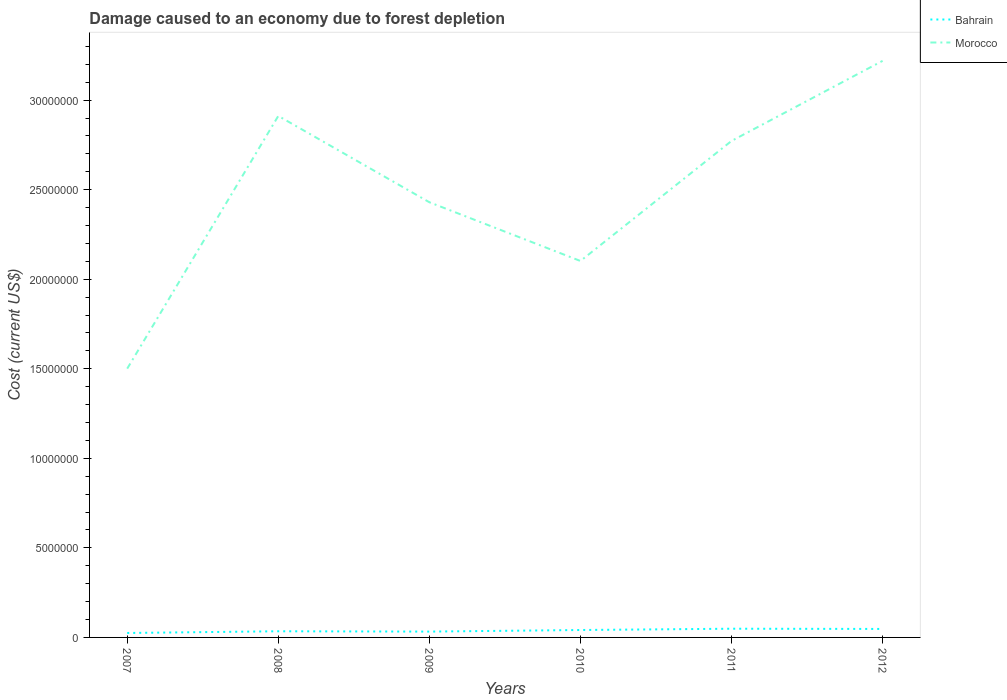Is the number of lines equal to the number of legend labels?
Provide a succinct answer. Yes. Across all years, what is the maximum cost of damage caused due to forest depletion in Bahrain?
Your response must be concise. 2.48e+05. What is the total cost of damage caused due to forest depletion in Bahrain in the graph?
Keep it short and to the point. -1.66e+05. What is the difference between the highest and the second highest cost of damage caused due to forest depletion in Morocco?
Provide a succinct answer. 1.72e+07. Is the cost of damage caused due to forest depletion in Bahrain strictly greater than the cost of damage caused due to forest depletion in Morocco over the years?
Provide a short and direct response. Yes. How many years are there in the graph?
Your answer should be compact. 6. Where does the legend appear in the graph?
Provide a succinct answer. Top right. How are the legend labels stacked?
Give a very brief answer. Vertical. What is the title of the graph?
Provide a short and direct response. Damage caused to an economy due to forest depletion. What is the label or title of the X-axis?
Provide a succinct answer. Years. What is the label or title of the Y-axis?
Your answer should be compact. Cost (current US$). What is the Cost (current US$) of Bahrain in 2007?
Provide a short and direct response. 2.48e+05. What is the Cost (current US$) in Morocco in 2007?
Give a very brief answer. 1.50e+07. What is the Cost (current US$) of Bahrain in 2008?
Your answer should be very brief. 3.44e+05. What is the Cost (current US$) of Morocco in 2008?
Provide a succinct answer. 2.91e+07. What is the Cost (current US$) of Bahrain in 2009?
Offer a very short reply. 3.26e+05. What is the Cost (current US$) of Morocco in 2009?
Your response must be concise. 2.43e+07. What is the Cost (current US$) of Bahrain in 2010?
Your answer should be compact. 4.14e+05. What is the Cost (current US$) of Morocco in 2010?
Ensure brevity in your answer.  2.10e+07. What is the Cost (current US$) in Bahrain in 2011?
Your response must be concise. 4.86e+05. What is the Cost (current US$) of Morocco in 2011?
Ensure brevity in your answer.  2.77e+07. What is the Cost (current US$) in Bahrain in 2012?
Offer a terse response. 4.73e+05. What is the Cost (current US$) in Morocco in 2012?
Make the answer very short. 3.22e+07. Across all years, what is the maximum Cost (current US$) of Bahrain?
Provide a short and direct response. 4.86e+05. Across all years, what is the maximum Cost (current US$) of Morocco?
Offer a terse response. 3.22e+07. Across all years, what is the minimum Cost (current US$) in Bahrain?
Give a very brief answer. 2.48e+05. Across all years, what is the minimum Cost (current US$) in Morocco?
Ensure brevity in your answer.  1.50e+07. What is the total Cost (current US$) in Bahrain in the graph?
Offer a very short reply. 2.29e+06. What is the total Cost (current US$) of Morocco in the graph?
Offer a terse response. 1.49e+08. What is the difference between the Cost (current US$) of Bahrain in 2007 and that in 2008?
Keep it short and to the point. -9.60e+04. What is the difference between the Cost (current US$) in Morocco in 2007 and that in 2008?
Provide a succinct answer. -1.41e+07. What is the difference between the Cost (current US$) in Bahrain in 2007 and that in 2009?
Provide a succinct answer. -7.75e+04. What is the difference between the Cost (current US$) of Morocco in 2007 and that in 2009?
Offer a very short reply. -9.29e+06. What is the difference between the Cost (current US$) of Bahrain in 2007 and that in 2010?
Give a very brief answer. -1.66e+05. What is the difference between the Cost (current US$) of Morocco in 2007 and that in 2010?
Give a very brief answer. -6.01e+06. What is the difference between the Cost (current US$) in Bahrain in 2007 and that in 2011?
Ensure brevity in your answer.  -2.38e+05. What is the difference between the Cost (current US$) in Morocco in 2007 and that in 2011?
Provide a short and direct response. -1.27e+07. What is the difference between the Cost (current US$) in Bahrain in 2007 and that in 2012?
Offer a terse response. -2.25e+05. What is the difference between the Cost (current US$) in Morocco in 2007 and that in 2012?
Offer a very short reply. -1.72e+07. What is the difference between the Cost (current US$) in Bahrain in 2008 and that in 2009?
Your answer should be compact. 1.85e+04. What is the difference between the Cost (current US$) of Morocco in 2008 and that in 2009?
Your response must be concise. 4.82e+06. What is the difference between the Cost (current US$) in Bahrain in 2008 and that in 2010?
Provide a succinct answer. -7.02e+04. What is the difference between the Cost (current US$) of Morocco in 2008 and that in 2010?
Keep it short and to the point. 8.10e+06. What is the difference between the Cost (current US$) of Bahrain in 2008 and that in 2011?
Give a very brief answer. -1.42e+05. What is the difference between the Cost (current US$) in Morocco in 2008 and that in 2011?
Your answer should be compact. 1.40e+06. What is the difference between the Cost (current US$) in Bahrain in 2008 and that in 2012?
Make the answer very short. -1.29e+05. What is the difference between the Cost (current US$) of Morocco in 2008 and that in 2012?
Give a very brief answer. -3.07e+06. What is the difference between the Cost (current US$) in Bahrain in 2009 and that in 2010?
Provide a short and direct response. -8.86e+04. What is the difference between the Cost (current US$) in Morocco in 2009 and that in 2010?
Provide a succinct answer. 3.28e+06. What is the difference between the Cost (current US$) in Bahrain in 2009 and that in 2011?
Your answer should be compact. -1.61e+05. What is the difference between the Cost (current US$) of Morocco in 2009 and that in 2011?
Provide a succinct answer. -3.42e+06. What is the difference between the Cost (current US$) in Bahrain in 2009 and that in 2012?
Offer a very short reply. -1.48e+05. What is the difference between the Cost (current US$) of Morocco in 2009 and that in 2012?
Make the answer very short. -7.89e+06. What is the difference between the Cost (current US$) of Bahrain in 2010 and that in 2011?
Your response must be concise. -7.19e+04. What is the difference between the Cost (current US$) of Morocco in 2010 and that in 2011?
Ensure brevity in your answer.  -6.70e+06. What is the difference between the Cost (current US$) of Bahrain in 2010 and that in 2012?
Make the answer very short. -5.91e+04. What is the difference between the Cost (current US$) of Morocco in 2010 and that in 2012?
Offer a very short reply. -1.12e+07. What is the difference between the Cost (current US$) of Bahrain in 2011 and that in 2012?
Keep it short and to the point. 1.28e+04. What is the difference between the Cost (current US$) of Morocco in 2011 and that in 2012?
Offer a very short reply. -4.47e+06. What is the difference between the Cost (current US$) of Bahrain in 2007 and the Cost (current US$) of Morocco in 2008?
Your response must be concise. -2.89e+07. What is the difference between the Cost (current US$) in Bahrain in 2007 and the Cost (current US$) in Morocco in 2009?
Your response must be concise. -2.40e+07. What is the difference between the Cost (current US$) of Bahrain in 2007 and the Cost (current US$) of Morocco in 2010?
Your answer should be very brief. -2.08e+07. What is the difference between the Cost (current US$) in Bahrain in 2007 and the Cost (current US$) in Morocco in 2011?
Provide a succinct answer. -2.75e+07. What is the difference between the Cost (current US$) in Bahrain in 2007 and the Cost (current US$) in Morocco in 2012?
Ensure brevity in your answer.  -3.19e+07. What is the difference between the Cost (current US$) in Bahrain in 2008 and the Cost (current US$) in Morocco in 2009?
Your answer should be compact. -2.40e+07. What is the difference between the Cost (current US$) in Bahrain in 2008 and the Cost (current US$) in Morocco in 2010?
Your response must be concise. -2.07e+07. What is the difference between the Cost (current US$) of Bahrain in 2008 and the Cost (current US$) of Morocco in 2011?
Make the answer very short. -2.74e+07. What is the difference between the Cost (current US$) in Bahrain in 2008 and the Cost (current US$) in Morocco in 2012?
Provide a short and direct response. -3.18e+07. What is the difference between the Cost (current US$) in Bahrain in 2009 and the Cost (current US$) in Morocco in 2010?
Offer a terse response. -2.07e+07. What is the difference between the Cost (current US$) of Bahrain in 2009 and the Cost (current US$) of Morocco in 2011?
Offer a terse response. -2.74e+07. What is the difference between the Cost (current US$) in Bahrain in 2009 and the Cost (current US$) in Morocco in 2012?
Offer a terse response. -3.19e+07. What is the difference between the Cost (current US$) of Bahrain in 2010 and the Cost (current US$) of Morocco in 2011?
Ensure brevity in your answer.  -2.73e+07. What is the difference between the Cost (current US$) of Bahrain in 2010 and the Cost (current US$) of Morocco in 2012?
Your answer should be compact. -3.18e+07. What is the difference between the Cost (current US$) of Bahrain in 2011 and the Cost (current US$) of Morocco in 2012?
Your answer should be very brief. -3.17e+07. What is the average Cost (current US$) in Bahrain per year?
Provide a short and direct response. 3.82e+05. What is the average Cost (current US$) of Morocco per year?
Offer a terse response. 2.49e+07. In the year 2007, what is the difference between the Cost (current US$) of Bahrain and Cost (current US$) of Morocco?
Offer a terse response. -1.48e+07. In the year 2008, what is the difference between the Cost (current US$) of Bahrain and Cost (current US$) of Morocco?
Keep it short and to the point. -2.88e+07. In the year 2009, what is the difference between the Cost (current US$) of Bahrain and Cost (current US$) of Morocco?
Ensure brevity in your answer.  -2.40e+07. In the year 2010, what is the difference between the Cost (current US$) in Bahrain and Cost (current US$) in Morocco?
Offer a terse response. -2.06e+07. In the year 2011, what is the difference between the Cost (current US$) in Bahrain and Cost (current US$) in Morocco?
Offer a very short reply. -2.72e+07. In the year 2012, what is the difference between the Cost (current US$) of Bahrain and Cost (current US$) of Morocco?
Provide a succinct answer. -3.17e+07. What is the ratio of the Cost (current US$) of Bahrain in 2007 to that in 2008?
Offer a terse response. 0.72. What is the ratio of the Cost (current US$) of Morocco in 2007 to that in 2008?
Make the answer very short. 0.52. What is the ratio of the Cost (current US$) in Bahrain in 2007 to that in 2009?
Your answer should be very brief. 0.76. What is the ratio of the Cost (current US$) in Morocco in 2007 to that in 2009?
Offer a terse response. 0.62. What is the ratio of the Cost (current US$) of Bahrain in 2007 to that in 2010?
Give a very brief answer. 0.6. What is the ratio of the Cost (current US$) of Morocco in 2007 to that in 2010?
Provide a succinct answer. 0.71. What is the ratio of the Cost (current US$) in Bahrain in 2007 to that in 2011?
Offer a very short reply. 0.51. What is the ratio of the Cost (current US$) in Morocco in 2007 to that in 2011?
Give a very brief answer. 0.54. What is the ratio of the Cost (current US$) of Bahrain in 2007 to that in 2012?
Give a very brief answer. 0.52. What is the ratio of the Cost (current US$) of Morocco in 2007 to that in 2012?
Your response must be concise. 0.47. What is the ratio of the Cost (current US$) of Bahrain in 2008 to that in 2009?
Offer a terse response. 1.06. What is the ratio of the Cost (current US$) of Morocco in 2008 to that in 2009?
Offer a terse response. 1.2. What is the ratio of the Cost (current US$) in Bahrain in 2008 to that in 2010?
Provide a succinct answer. 0.83. What is the ratio of the Cost (current US$) of Morocco in 2008 to that in 2010?
Your answer should be very brief. 1.39. What is the ratio of the Cost (current US$) in Bahrain in 2008 to that in 2011?
Your answer should be very brief. 0.71. What is the ratio of the Cost (current US$) in Morocco in 2008 to that in 2011?
Your answer should be very brief. 1.05. What is the ratio of the Cost (current US$) in Bahrain in 2008 to that in 2012?
Your response must be concise. 0.73. What is the ratio of the Cost (current US$) in Morocco in 2008 to that in 2012?
Ensure brevity in your answer.  0.9. What is the ratio of the Cost (current US$) of Bahrain in 2009 to that in 2010?
Your answer should be compact. 0.79. What is the ratio of the Cost (current US$) of Morocco in 2009 to that in 2010?
Your response must be concise. 1.16. What is the ratio of the Cost (current US$) in Bahrain in 2009 to that in 2011?
Your response must be concise. 0.67. What is the ratio of the Cost (current US$) in Morocco in 2009 to that in 2011?
Offer a terse response. 0.88. What is the ratio of the Cost (current US$) in Bahrain in 2009 to that in 2012?
Your response must be concise. 0.69. What is the ratio of the Cost (current US$) in Morocco in 2009 to that in 2012?
Provide a succinct answer. 0.75. What is the ratio of the Cost (current US$) of Bahrain in 2010 to that in 2011?
Keep it short and to the point. 0.85. What is the ratio of the Cost (current US$) in Morocco in 2010 to that in 2011?
Ensure brevity in your answer.  0.76. What is the ratio of the Cost (current US$) of Bahrain in 2010 to that in 2012?
Offer a very short reply. 0.88. What is the ratio of the Cost (current US$) in Morocco in 2010 to that in 2012?
Ensure brevity in your answer.  0.65. What is the ratio of the Cost (current US$) in Morocco in 2011 to that in 2012?
Keep it short and to the point. 0.86. What is the difference between the highest and the second highest Cost (current US$) of Bahrain?
Give a very brief answer. 1.28e+04. What is the difference between the highest and the second highest Cost (current US$) of Morocco?
Offer a very short reply. 3.07e+06. What is the difference between the highest and the lowest Cost (current US$) of Bahrain?
Offer a terse response. 2.38e+05. What is the difference between the highest and the lowest Cost (current US$) in Morocco?
Keep it short and to the point. 1.72e+07. 